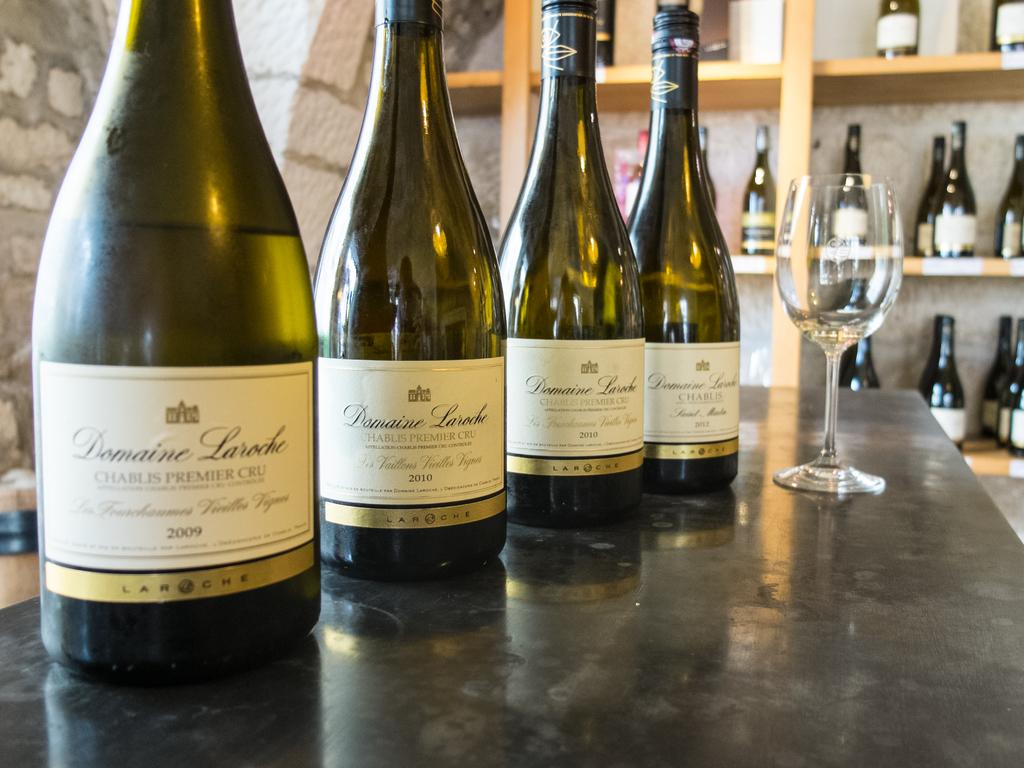Provide a one-sentence caption for the provided image. Four wine bottles of Domaine Laroche on a counter with a wine glass with several bottles in the background. 